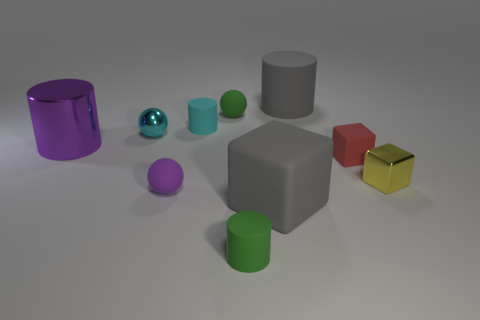Subtract all big matte cubes. How many cubes are left? 2 Subtract 1 cylinders. How many cylinders are left? 3 Subtract all gray cylinders. How many cylinders are left? 3 Subtract all cylinders. How many objects are left? 6 Add 10 blue things. How many blue things exist? 10 Subtract 0 green blocks. How many objects are left? 10 Subtract all gray cylinders. Subtract all gray cubes. How many cylinders are left? 3 Subtract all rubber things. Subtract all small matte spheres. How many objects are left? 1 Add 9 big rubber blocks. How many big rubber blocks are left? 10 